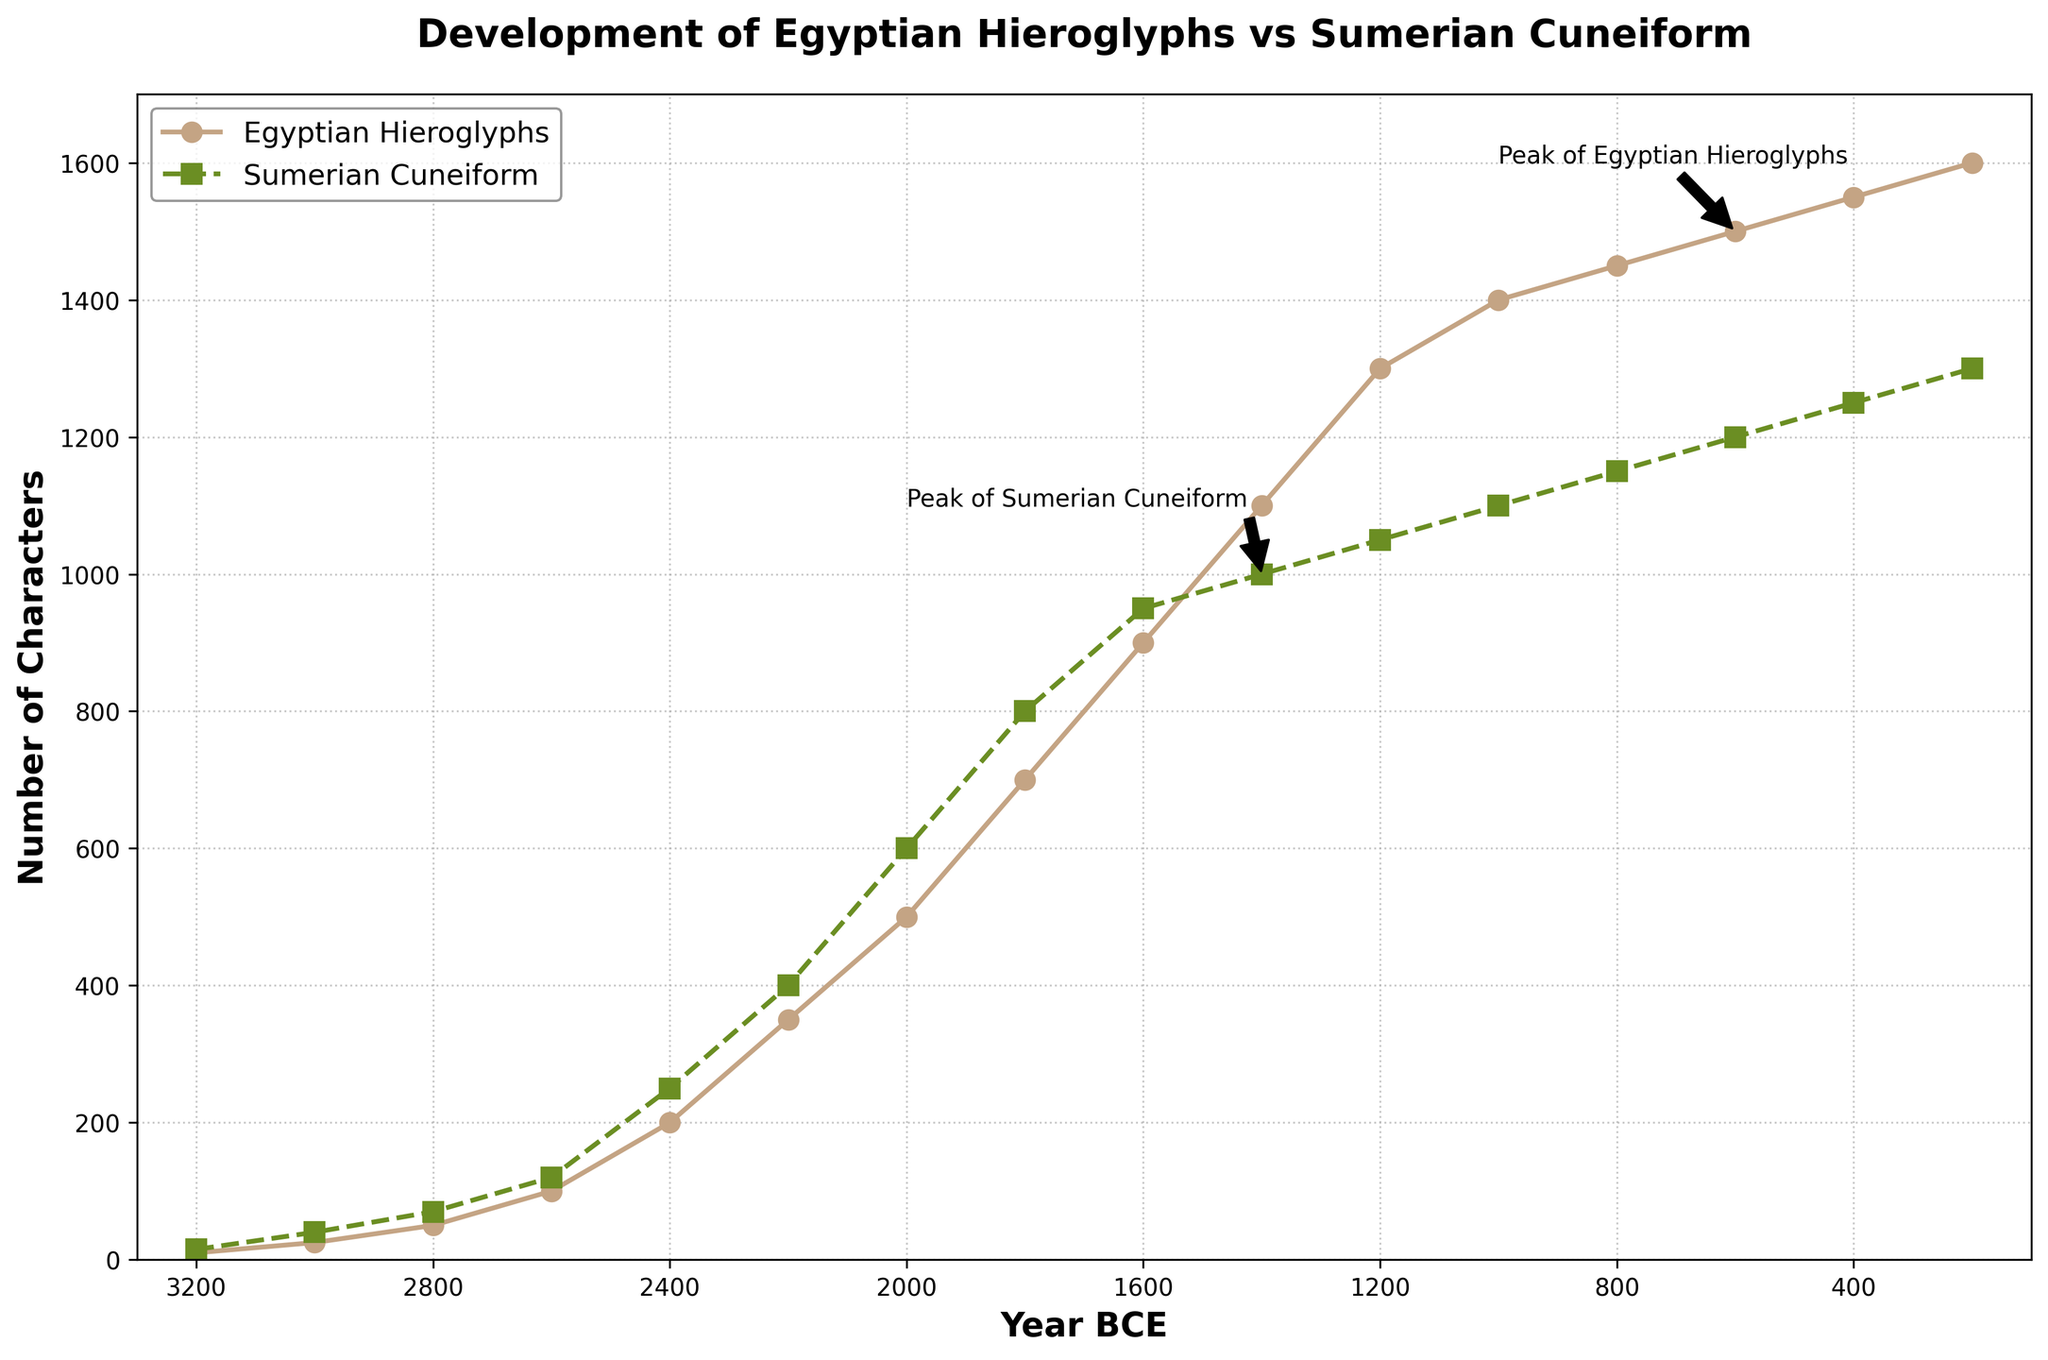What is the difference in the number of characters between Egyptian Hieroglyphs and Sumerian Cuneiform in 2000 BCE? To find the difference, locate the data points for 2000 BCE, which are 500 for Egyptian Hieroglyphs and 600 for Sumerian Cuneiform. Subtract the number of Egyptian Hieroglyph characters from the number of Sumerian Cuneiform characters: 600 - 500 = 100.
Answer: 100 Which writing system has a greater number of characters in 600 BCE? Look at the data points for 600 BCE. Egyptian Hieroglyphs have 1500 characters, and Sumerian Cuneiform has 1200 characters. Since 1500 > 1200, Egyptian Hieroglyphs have more characters.
Answer: Egyptian Hieroglyphs By how much did the number of Egyptian Hieroglyphic characters increase from 2600 BCE to 2200 BCE? Find the data points for 2600 BCE and 2200 BCE. In 2600 BCE, there are 100 characters, and in 2200 BCE, there are 350 characters. Subtract the number of characters in 2600 BCE from that in 2200 BCE: 350 - 100 = 250.
Answer: 250 What is the peak number of characters for Sumerian Cuneiform during the timeline presented? Look at the data trend for Sumerian Cuneiform and find the maximum value. The peak occurs at 2000 BCE with 1300 characters.
Answer: 1300 How did the number of Egyptian Hieroglyphic characters change between 800 BCE and 200 BCE? Observe the data at 800 BCE (1450 characters) and 200 BCE (1600 characters). Calculate the change: 1600 - 1450 = 150.
Answer: Increased by 150 What is the average number of characters for Egyptian Hieroglyphs over the timeline? Sum all the values for Egyptian Hieroglyphs and divide by the number of data points. The sum is 10 + 25 + 50 + 100 + 200 + 350 + 500 + 700 + 900 + 1100 + 1300 + 1400 + 1450 + 1500 + 1550 + 1600 = 14635. There are 15 data points, so the average is 14635 / 15 ≈ 975.67.
Answer: 975.67 Which year shows both writing systems having the closest number of characters? Compare the difference in the number of characters each year. The closest difference is in 1400 BCE where Egyptian Hieroglyphs have 1100 characters, and Sumerian Cuneiform has 1000 characters, a difference of 100 characters.
Answer: 1400 BCE At what year does the data show an equal number of characters for both writing systems? The data never shows an equal number of characters for both writing systems.
Answer: Never Which writing system shows a greater increase in the number of characters between 3200 BCE and 1000 BCE? Calculate the increase for both systems from 3200 BCE to 1000 BCE. For Egyptian Hieroglyphs: 1400 - 10 = 1390. For Sumerian Cuneiform: 1100 - 15 = 1085. Since 1390 > 1085, Egyptian Hieroglyphs show a greater increase.
Answer: Egyptian Hieroglyphs In what year do both systems have more than 1000 characters? Check the data for both writing systems having more than 1000 characters. This condition is met in 1400 BCE for Sumerian Cuneiform and in 1200 BCE for Egyptian Hieroglyphs. Considering the earliest occurrence, it's 1400 BCE.
Answer: 1400 BCE 